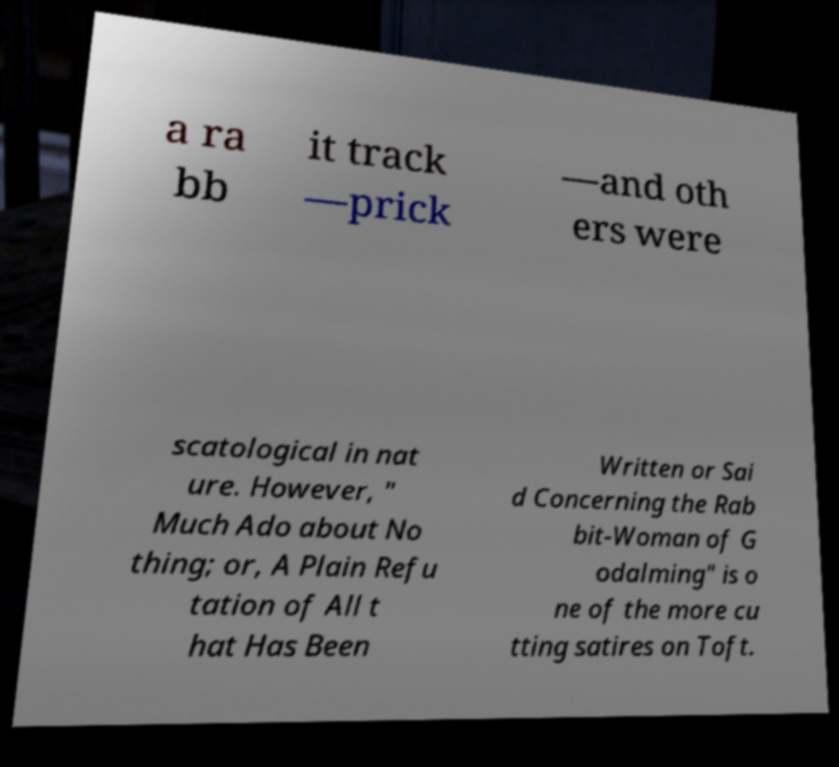Can you accurately transcribe the text from the provided image for me? a ra bb it track —prick —and oth ers were scatological in nat ure. However, " Much Ado about No thing; or, A Plain Refu tation of All t hat Has Been Written or Sai d Concerning the Rab bit-Woman of G odalming" is o ne of the more cu tting satires on Toft. 